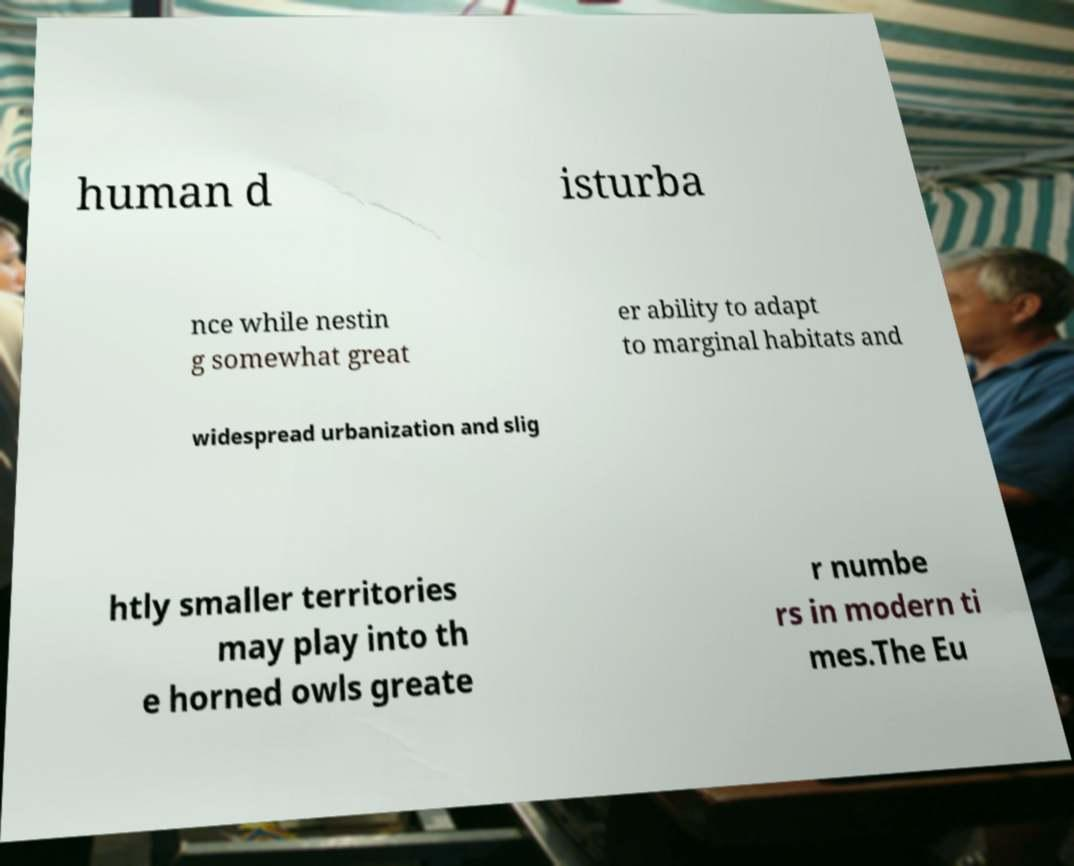Please read and relay the text visible in this image. What does it say? human d isturba nce while nestin g somewhat great er ability to adapt to marginal habitats and widespread urbanization and slig htly smaller territories may play into th e horned owls greate r numbe rs in modern ti mes.The Eu 